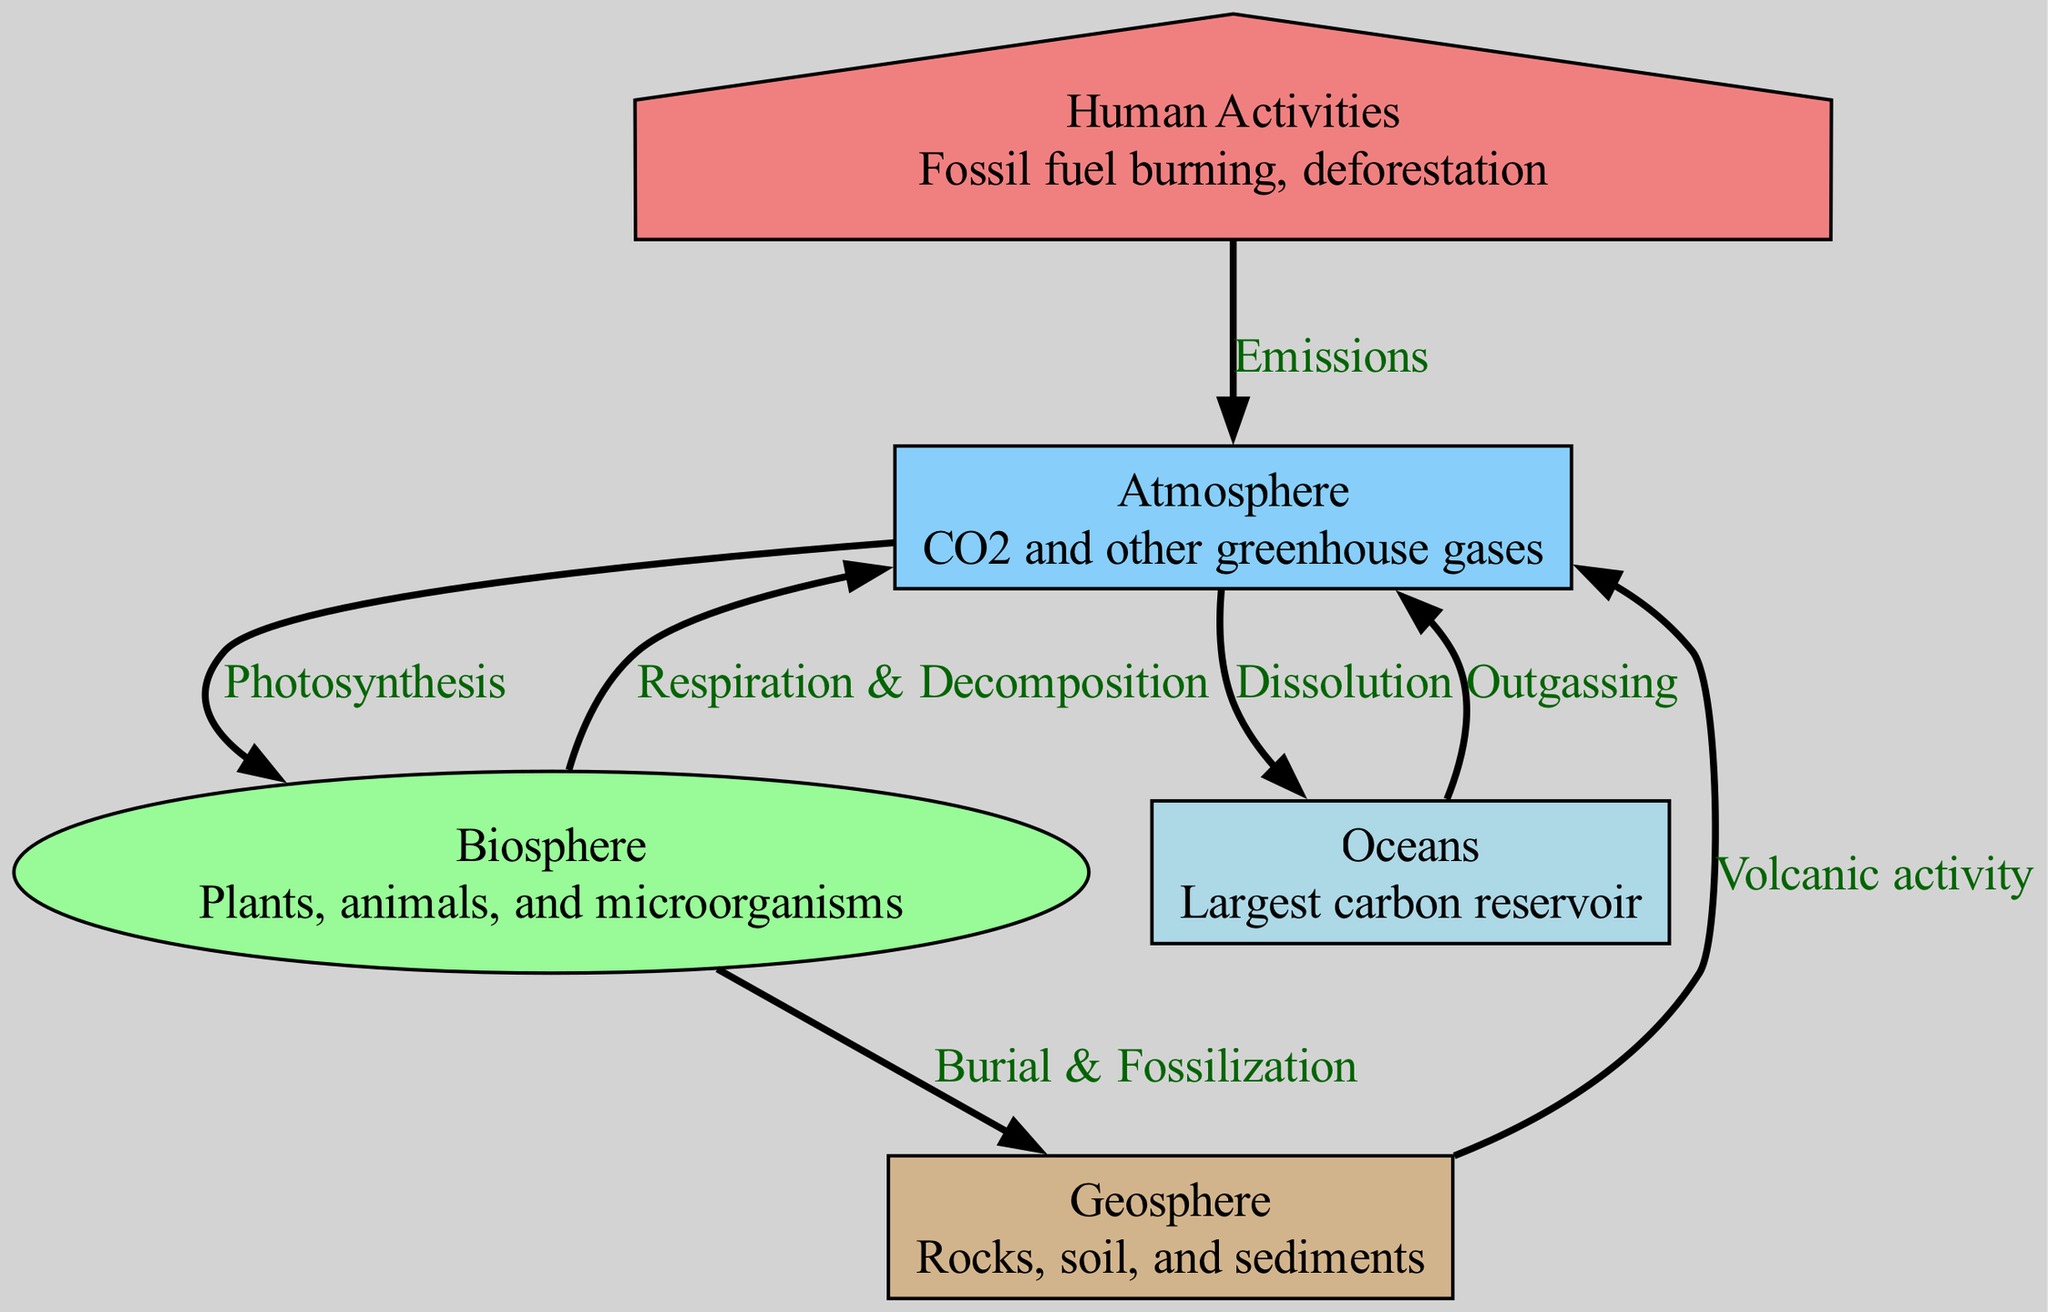What are the three main components of the carbon cycle? The diagram features three main components represented as nodes: Atmosphere, Biosphere, and Geosphere.
Answer: Atmosphere, Biosphere, Geosphere How many nodes are present in the carbon cycle diagram? By counting the unique identified nodes in the diagram, we find there are five nodes: Atmosphere, Biosphere, Geosphere, Oceans, and Human Activities.
Answer: 5 Which process transfers carbon from the atmosphere to the biosphere? The edge labeled "Photosynthesis" indicates the process whereby carbon moves from the atmosphere to the biosphere.
Answer: Photosynthesis What is the connection between the geosphere and the atmosphere? The relationship is indicated by the edge labeled "Volcanic activity," which shows how carbon can transfer from the geosphere to the atmosphere.
Answer: Volcanic activity What is the largest carbon reservoir depicted in the diagram? The node labeled "Oceans" signifies that it is the largest carbon reservoir in the carbon cycle.
Answer: Oceans How does human activity impact the carbon cycle according to the diagram? The edge labeled "Emissions" illustrates that human activities contribute carbon to the atmosphere.
Answer: Emissions What process is represented by the biosphere returning carbon to the atmosphere? The "Respiration & Decomposition" edge indicates the process by which carbon is returned to the atmosphere from the biosphere.
Answer: Respiration & Decomposition What is the relationship between biosphere and geosphere? The edge labeled "Burial & Fossilization" shows the transfer of carbon from the biosphere to the geosphere.
Answer: Burial & Fossilization How is carbon exchanged between oceans and the atmosphere? The diagram shows two edges: "Dissolution" for carbon entering the oceans and "Outgassing" for carbon leaving the oceans to return to the atmosphere.
Answer: Dissolution, Outgassing 